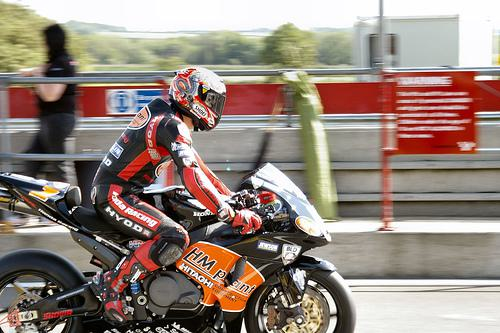What kind of event does this image depict? This image captures a moment from a motorcycle racing event, characterized by the racer in a professional racing suit and a high-performance sports bike on what appears to be a racetrack. Can you tell me more about the motorcycle? Certainly! The motorcycle is a sportbike, optimized for speed, acceleration, braking, and cornering on paved roads. It's adorned with racing decals and sponsor logos, which suggests it's part of a professional racing team. The features like its aerodynamic body, racing tires, and advanced suspension are all indicative of high-performance machinery designed for competitive racing. 